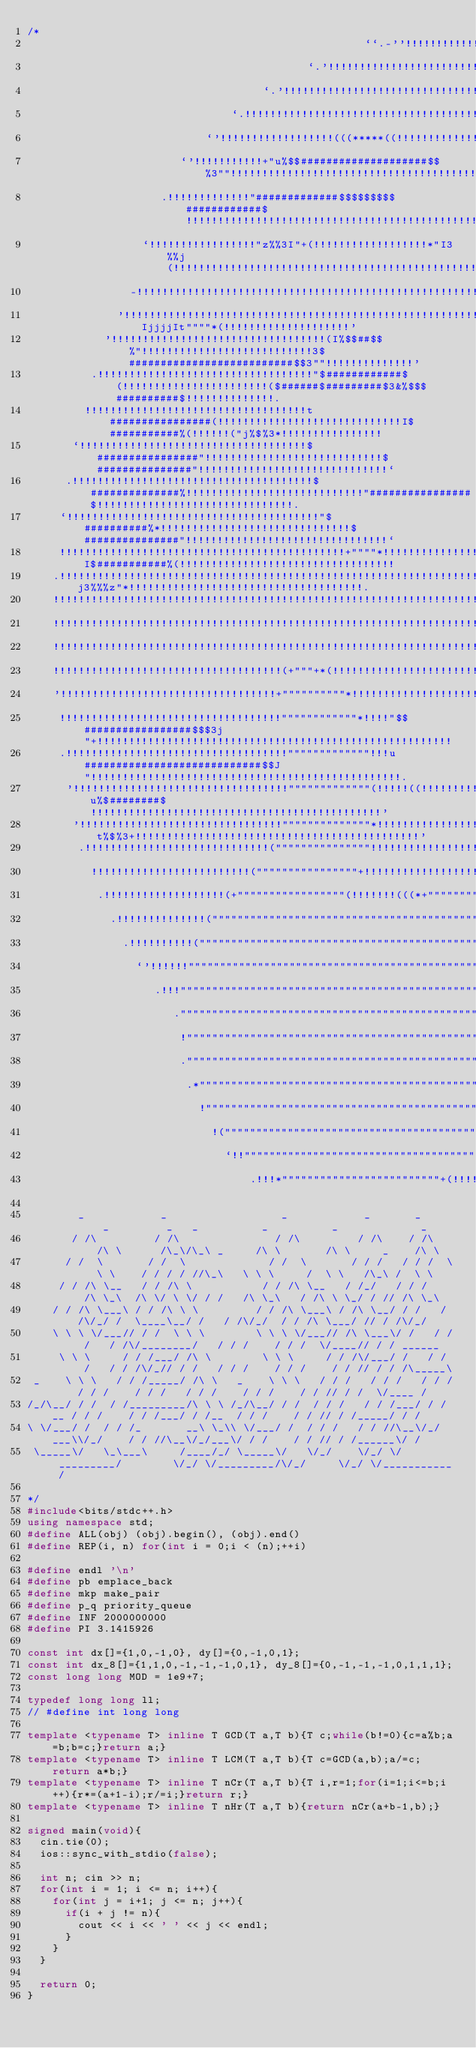<code> <loc_0><loc_0><loc_500><loc_500><_C++_>/*
                                                     ``.-''!!!!!!!!!!!!!!!!!!!!!!!!!!!''-..`                                                     
                                            `.'!!!!!!!!!!!!!!!!!!!!!!!!!!!!!!!!!!!!!!!!!!!!!!!!!!!'.`                                            
                                     `.'!!!!!!!!!!!!!!!!!!!!!!!!!!!!!!!!!!!!!!!!!!!!!!!!!!!!!!!!!!!!!!!!!'.`                                     
                                `.!!!!!!!!!!!!!!!!!!!!!!!!!!!!!!!!!!!!!!!!!!!!!!!!!!!!!!!!!!!!!!!!!!!!!!!!!!!!!.`                                
                            `'!!!!!!!!!!!!!!!!!!(((*****((!!!!!!!!!!!!!!!!!!!!!!!!!!!!!!!!!!!!!!!!!!!!!!!!!!!!!!!!!'`                            
                        `'!!!!!!!!!!!+"u%$$####################$$%3""!!!!!!!!!!!!!!!!!!!!!!!!!!!!!!!!!!!!!!!!!!!!!!!!!!'`                        
                     .!!!!!!!!!!!!!"#############$$$$$$$$$############$!!!!!!!!!!!!!!!!!!!!!!!!!!!!!!!!!!!!!!!!!!!!!!!!!!!!.                     
                  `!!!!!!!!!!!!!!!!!"z%%3I"+(!!!!!!!!!!!!!!!!!!*"I3%%j(!!!!!!!!!!!!!!!!!!!!!!!!!!!!!!!!!!!!!!!!!!!!!!!!!!!!!!!`                  
                -!!!!!!!!!!!!!!!!!!!!!!!!!!!!!!!!!!!!!!!!!!!!!!!!!!!!!!!!!!!!!!!!!!!!!!!!!!!!!!!!!!!!!!!!!!!!!!!!!!!!!!!!!!!!!!!-                
              '!!!!!!!!!!!!!!!!!!!!!!!!!!!!!!!!!!!!!!!!!!!!!!!!!!!!!!!!!!!!!!!!!!!!!!!!!!!(*"""""IjjjjIt""""*(!!!!!!!!!!!!!!!!!!!!'              
            '!!!!!!!!!!!!!!!!!!!!!!!!!!!!!!!!!!(I%$$##$$%"!!!!!!!!!!!!!!!!!!!!!!!!!!!3$##########################$$3""!!!!!!!!!!!!!!'            
          .!!!!!!!!!!!!!!!!!!!!!!!!!!!!!!!!!!"$############$(!!!!!!!!!!!!!!!!!!!!!!!($######$#########$3&%$$$##########$!!!!!!!!!!!!!!.          
         !!!!!!!!!!!!!!!!!!!!!!!!!!!!!!!!!!!t################(!!!!!!!!!!!!!!!!!!!!!!!!!!!!!I$###########%(!!!!!!("j%$%3*!!!!!!!!!!!!!!!!         
       `!!!!!!!!!!!!!!!!!!!!!!!!!!!!!!!!!!!!$################"!!!!!!!!!!!!!!!!!!!!!!!!!!!!$###############"!!!!!!!!!!!!!!!!!!!!!!!!!!!!!!`       
      .!!!!!!!!!!!!!!!!!!!!!!!!!!!!!!!!!!!!!!$##############%!!!!!!!!!!!!!!!!!!!!!!!!!!!!"################$!!!!!!!!!!!!!!!!!!!!!!!!!!!!!!!.      
     `!!!!!!!!!!!!!!!!!!!!!!!!!!!!!!!!!!!!!!!!"$##########%*!!!!!!!!!!!!!!!!!!!!!!!!!!!!!!$###############"!!!!!!!!!!!!!!!!!!!!!!!!!!!!!!!!`     
     !!!!!!!!!!!!!!!!!!!!!!!!!!!!!!!!!!!!!!!!!!!!!+""""*!!!!!!!!!!!!!!!!!!!!!!!!!!!!!!!!!!!I$###########%(!!!!!!!!!!!!!!!!!!!!!!!!!!!!!!!!!!     
    .!!!!!!!!!!!!!!!!!!!!!!!!!!!!!!!!!!!!!!!!!!!!!!!!!!!!!!!!!!!!!!!!!!!!!!!!!!!!!!!!!!!!!!!!!"j3%%%z"*!!!!!!!!!!!!!!!!!!!!!!!!!!!!!!!!!!!!!.    
    !!!!!!!!!!!!!!!!!!!!!!!!!!!!!!!!!!!!!!!!!!!!!!!!!!!!!!!!!!!!!!!!!!!!!!!!!!!!!!!!!!!!!!!!!!!!!!!!!!!!!!!!!!!!!!!!!!!!!!!!!!!!!!!!!!!!!!!!!    
    !!!!!!!!!!!!!!!!!!!!!!!!!!!!!!!!!!!!!!!!!!!!!!!!!!!!!!!!!!!!!!!!!!!!!!!!!!!!!!!!!!!!!!!!!!!!!!!!!!!!!!!!!!!!!!!!!!!!!!!!!!!!!!!!!!!!!!!!!    
    !!!!!!!!!!!!!!!!!!!!!!!!!!!!!!!!!!!!!!!!!!!!!!!!!!!!!!!!!!!!!!!!!!!!!!!!!!!!!!!!!!!!!!!!!!!!!!!!!!!!!!!!!!!!!!!!!!!!!!!!!!!!!!!!!!!!!!!!!    
    !!!!!!!!!!!!!!!!!!!!!!!!!!!!!!!!!!!!(+"""+*(!!!!!!!!!!!!!!!!!!!!!!!!!!!!!!!!!!!!!!!!!!!!!!!!!!!!!!!!!!!!!!!!!!!!!!!!!!!!!!!!!!!!!!!!!!!!!    
    '!!!!!!!!!!!!!!!!!!!!!!!!!!!!!!!!!!+""""""""""*!!!!!!!!!!!!!!!!!!!!!!!!!!!!!!!!!!!!!!!!!!!!!!!!!!!!!!!!!!!!!!!!!!!!!!!!!!!!!!!!!!!!!!!!!'    
     !!!!!!!!!!!!!!!!!!!!!!!!!!!!!!!!!!!""""""""""""*!!!!"$$#################$$$3j"+!!!!!!!!!!!!!!!!!!!!!!!!!!!!!!!!!!!!!!!!!!!!!!!!!!!!!!!!     
     .!!!!!!!!!!!!!!!!!!!!!!!!!!!!!!!!!!!"""""""""""""!!!u############################$$J"!!!!!!!!!!!!!!!!!!!!!!!!!!!!!!!!!!!!!!!!!!!!!!!!!.     
      '!!!!!!!!!!!!!!!!!!!!!!!!!!!!!!!!!!"""""""""""""(!!!!!((!!!!!!!!!!!!!!(*""u%$########$!!!!!!!!!!!!!!!!!!!!!!!!!!!!!!!!!!!!!!!!!!!!!!'      
       '!!!!!!!!!!!!!!!!!!!!!!!!!!!!!!!!""""""""""""""*!!!!!!!!!!!!!!!!!!!!!!!!!!!!!!+t%$%3+!!!!!!!!!!!!!!!!!!!!!!!!!!!!!!!!!!!!!!!!!!!!!'       
        .!!!!!!!!!!!!!!!!!!!!!!!!!!!!!("""""""""""""""!!!!!!!!!!!!!!!!!!!!!!!!!!!!!!!!!(((*+""""""+(!!!!!!!!!!!!!!!!!!!!!!!!!!!!!!!!!!!!.        
          !!!!!!!!!!!!!!!!!!!!!!!!!(""""""""""""""""+!!!!!!!!!!!!!!!!!!!!(((*+"""""""""""""""""""""""!!!!!!!!!!!!!!!!!!!!!!!!!!!!!!!!!!          
           .!!!!!!!!!!!!!!!!!!!(+"""""""""""""""""(!!!!!!!(((*+"""""""""""""""""""""""""""""""""""""(!!!!!!!!!!!!!!!!!!!!!!!!!!!!!!!!.           
             .!!!!!!!!!!!!!!("""""""""""""""""""""""""""""""""""""""""""""""""""""""""""""+*(((!!!!!!!!!!!!!!!!!!!!!!!!!!!!!!!!!!!!.             
               .!!!!!!!!!!("""""""""""""""""""""""""""""""""""""""""""""""""+*(((!!!!!!!!!!!!!!!!!!!!!!!!!!!!!!!!!!!!!!!!!!!!!!!!.               
                 `'!!!!!!"""""""""""""""""""""""""""""""""""""""""""""""""""(!!!!!!!!!!!!!!!!!!!!!!!!!!!!!!!!!!!!!!!!!!!!!!!!!'`                 
                    .!!!""""""""""""""""""""""""""""""""""""""""""""""""""""""!!!!!!!!!!!!!!!!!!!!!!!!!!!!!!!!!!!!!!!!!!!!!!.                    
                       ."""""""""""""""""""""""""""""""""""""""""""""""""""""!!!!!!!!!!!!!!!!!!!!!!!!!!!!!!!!!!!!!!!!!!!'`                       
                        !""""""""""""""""""""""""""""""""""""""""""""""""""(!!!!!!!!!!!!!!!!!!!!!!!!!!!!!!!!!!!!!!!!!.                           
                        .""""""""""""""""""""""""""""""""""""""""""""""""""""!!!!!!!!!!!!!!!!!!!!!!!!!!!!!!!!!!!'.                               
                         .*""""""""""""""""""""""""""""""""""""""""""""""""""!!!!!!!!!!!!!!!!!!!!!!!!!!!!!!'.                                    
                           !""""""""""""""""""""""""""""""""""""""""""""""(!!!!!!!!!!!!!!!!!!!!!!!!!'-.                                          
                             !(""""""""""""""""""""""""""""""""""""""""""""!!!!!!!!!!!!!!!!''.``                                                 
                               `!!""""""""""""""""""""""""""""""""""""""""!..`````                                                               
                                   .!!!*"""""""""""""""""""""""""+(!!!!!.                                                                        

        _            _                  _            _       _     _         _   _          _          _             _        
       / /\         / /\               / /\         / /\    / /\  /\ \      /\_\/\_\ _     /\ \       /\ \     _    /\ \      
      / /  \       / /  \             / /  \       / / /   / / /  \ \ \    / / / / //\_\   \ \ \     /  \ \   /\_\ /  \ \     
     / / /\ \__   / / /\ \           / / /\ \__   / /_/   / / /   /\ \_\  /\ \/ \ \/ / /   /\ \_\   / /\ \ \_/ / // /\ \_\    
    / / /\ \___\ / / /\ \ \         / / /\ \___\ / /\ \__/ / /   / /\/_/ /  \____\__/ /   / /\/_/  / / /\ \___/ // / /\/_/    
    \ \ \ \/___// / /  \ \ \        \ \ \ \/___// /\ \___\/ /   / / /   / /\/________/   / / /    / / /  \/____// / / ______  
     \ \ \     / / /___/ /\ \        \ \ \     / / /\/___/ /   / / /   / / /\/_// / /   / / /    / / /    / / // / / /\_____\ 
 _    \ \ \   / / /_____/ /\ \   _    \ \ \   / / /   / / /   / / /   / / /    / / /   / / /    / / /    / / // / /  \/____ / 
/_/\__/ / /  / /_________/\ \ \ /_/\__/ / /  / / /   / / /___/ / /__ / / /    / / /___/ / /__  / / /    / / // / /_____/ / /  
\ \/___/ /  / / /_       __\ \_\\ \/___/ /  / / /   / / //\__\/_/___\\/_/    / / //\__\/_/___\/ / /    / / // / /______\/ /   
 \_____\/   \_\___\     /____/_/ \_____\/   \/_/    \/_/ \/_________/        \/_/ \/_________/\/_/     \/_/ \/___________/    
                                                                                                                              
*/
#include<bits/stdc++.h>
using namespace std;
#define ALL(obj) (obj).begin(), (obj).end()
#define REP(i, n) for(int i = 0;i < (n);++i)

#define endl '\n'
#define pb emplace_back
#define mkp make_pair
#define p_q priority_queue
#define INF 2000000000
#define PI 3.1415926

const int dx[]={1,0,-1,0}, dy[]={0,-1,0,1};
const int dx_8[]={1,1,0,-1,-1,-1,0,1}, dy_8[]={0,-1,-1,-1,0,1,1,1};
const long long MOD = 1e9+7;

typedef long long ll;
// #define int long long

template <typename T> inline T GCD(T a,T b){T c;while(b!=0){c=a%b;a=b;b=c;}return a;}
template <typename T> inline T LCM(T a,T b){T c=GCD(a,b);a/=c;return a*b;}
template <typename T> inline T nCr(T a,T b){T i,r=1;for(i=1;i<=b;i++){r*=(a+1-i);r/=i;}return r;}
template <typename T> inline T nHr(T a,T b){return nCr(a+b-1,b);}

signed main(void){
  cin.tie(0);
  ios::sync_with_stdio(false);

  int n; cin >> n;
  for(int i = 1; i <= n; i++){
    for(int j = i+1; j <= n; j++){
      if(i + j != n){
        cout << i << ' ' << j << endl;
      }
    }
  }

  return 0;
}</code> 